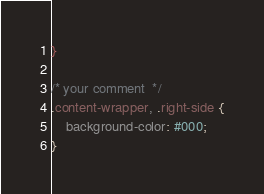<code> <loc_0><loc_0><loc_500><loc_500><_CSS_>}

/* your comment  */
.content-wrapper, .right-side {
    background-color: #000;
}</code> 